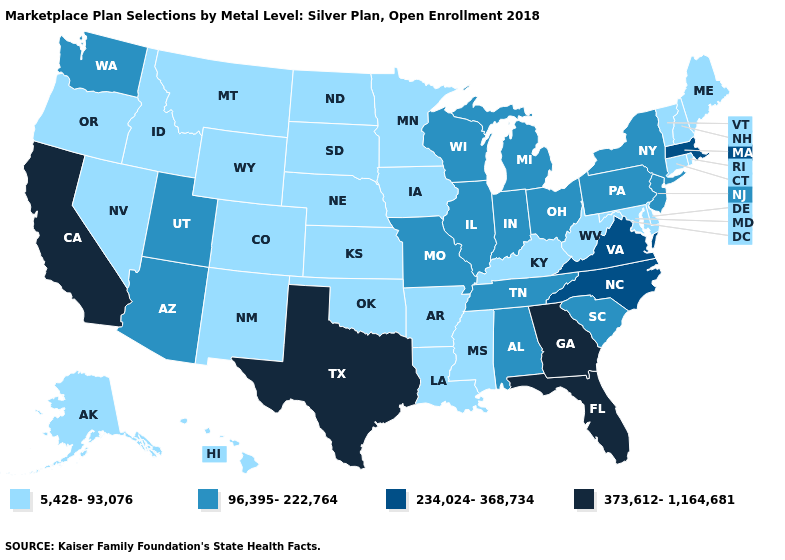Does South Carolina have the same value as Hawaii?
Be succinct. No. Name the states that have a value in the range 373,612-1,164,681?
Concise answer only. California, Florida, Georgia, Texas. Which states hav the highest value in the West?
Keep it brief. California. Name the states that have a value in the range 234,024-368,734?
Be succinct. Massachusetts, North Carolina, Virginia. Does Texas have the lowest value in the USA?
Keep it brief. No. How many symbols are there in the legend?
Quick response, please. 4. Which states have the lowest value in the South?
Keep it brief. Arkansas, Delaware, Kentucky, Louisiana, Maryland, Mississippi, Oklahoma, West Virginia. Does Massachusetts have the highest value in the Northeast?
Quick response, please. Yes. Does the map have missing data?
Concise answer only. No. What is the value of Tennessee?
Answer briefly. 96,395-222,764. Does Florida have the highest value in the USA?
Answer briefly. Yes. Among the states that border Illinois , does Wisconsin have the lowest value?
Short answer required. No. Among the states that border Massachusetts , does New York have the highest value?
Be succinct. Yes. What is the highest value in the Northeast ?
Write a very short answer. 234,024-368,734. 